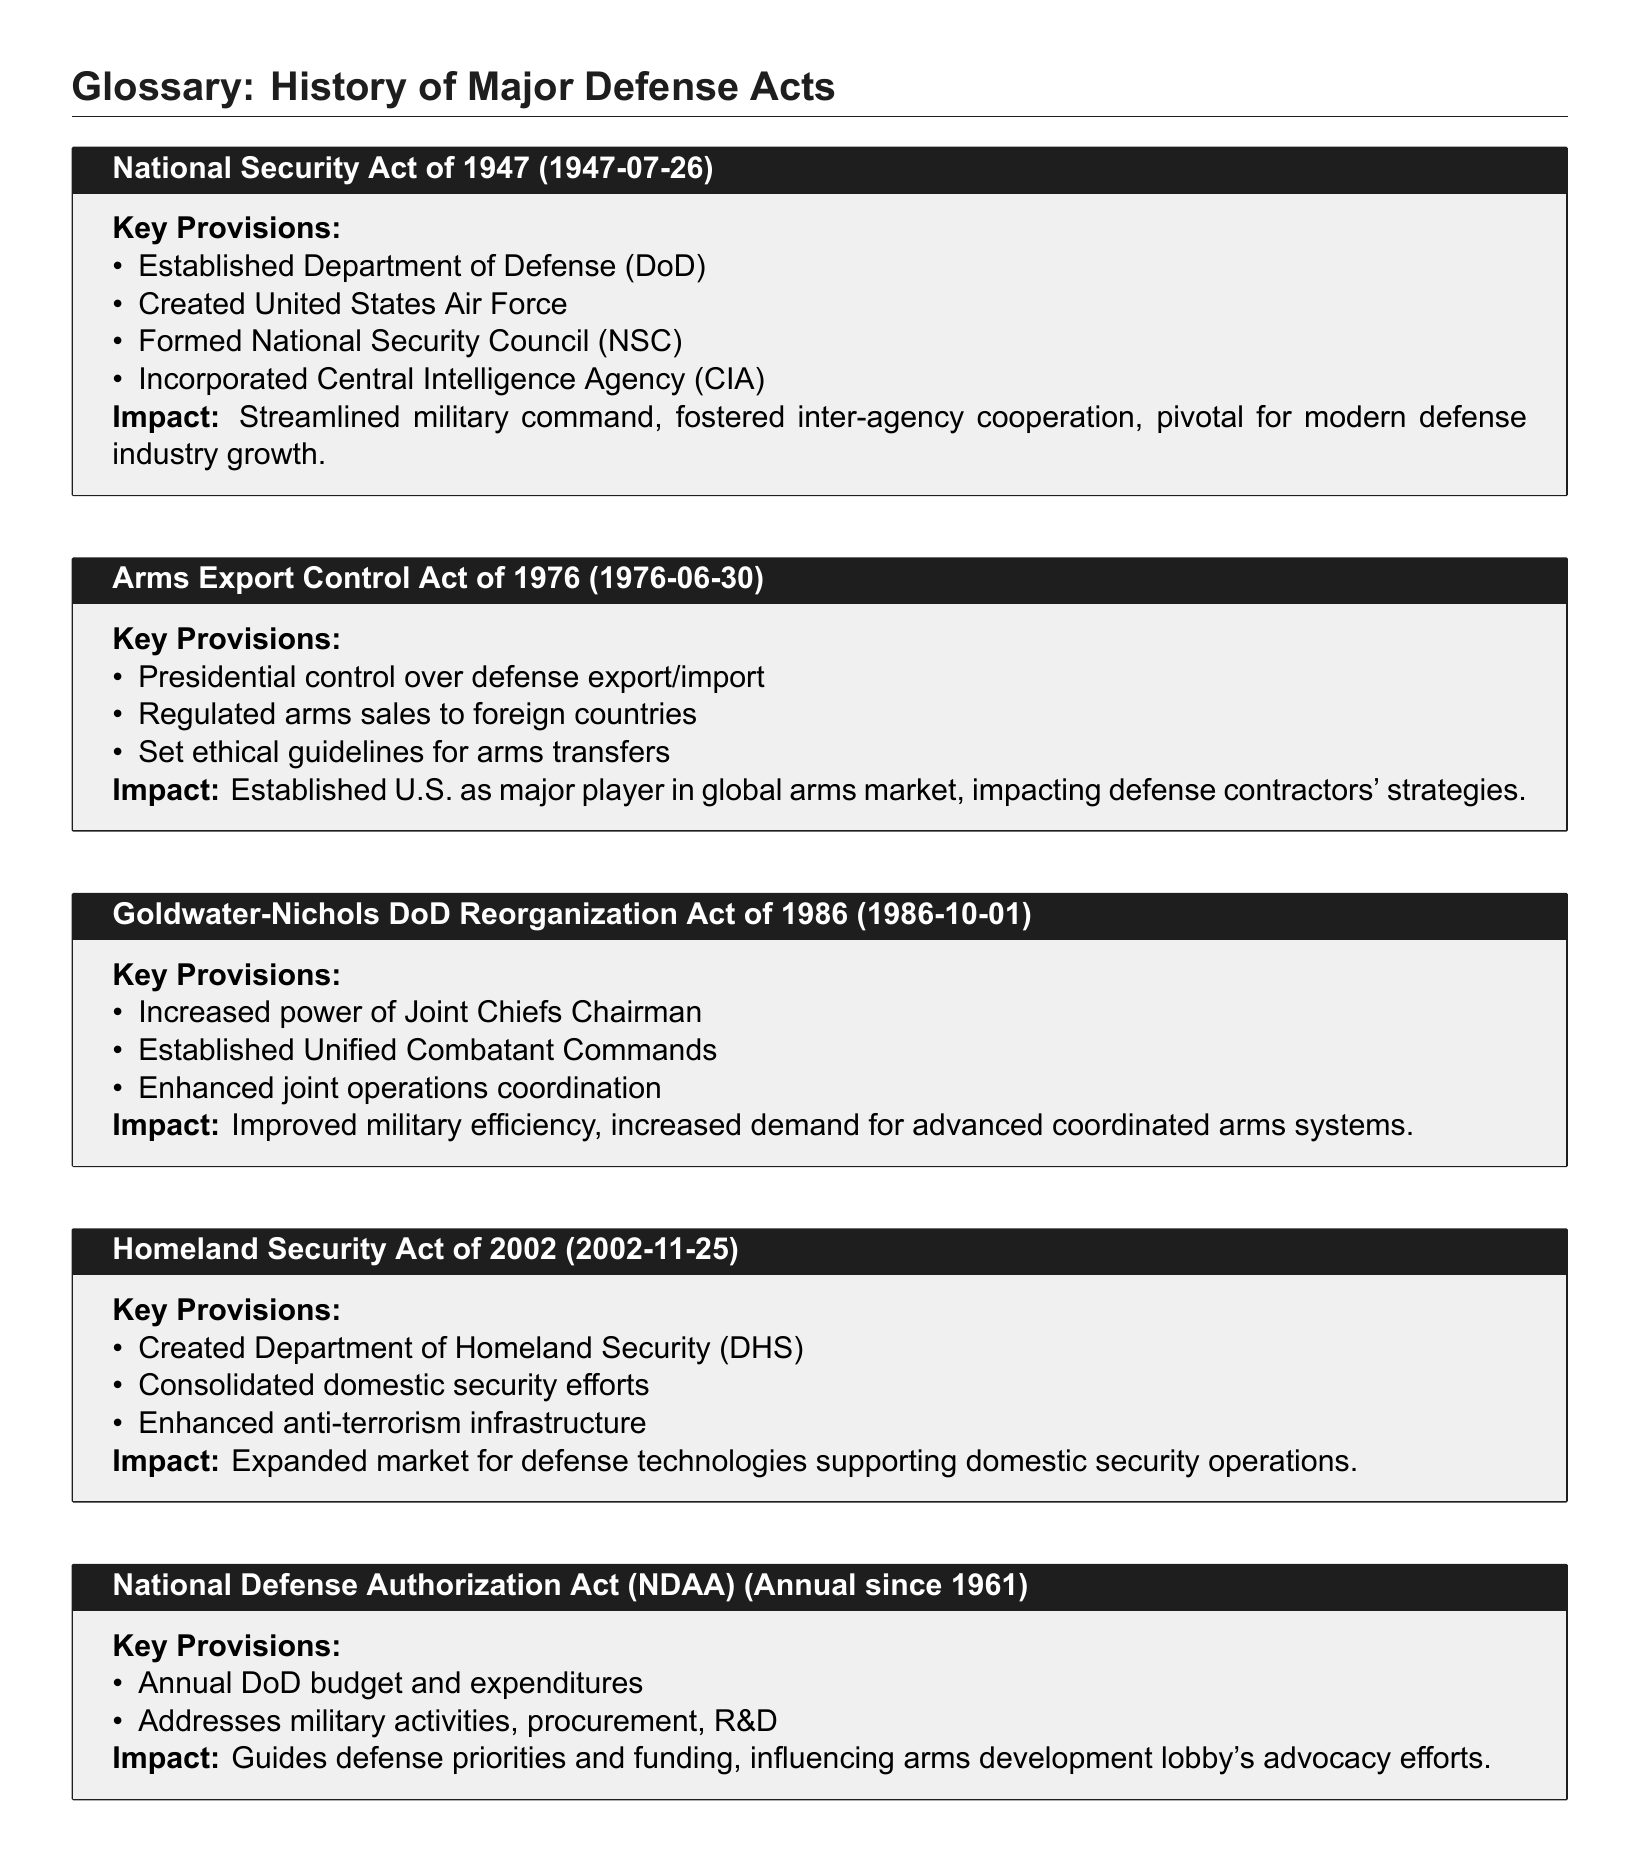What date was the National Security Act enacted? The National Security Act was enacted on July 26, 1947.
Answer: July 26, 1947 What agency was created by the National Security Act of 1947? The National Security Act created the United States Air Force.
Answer: United States Air Force Which act established presidential control over defense exports? The Arms Export Control Act of 1976 established presidential control over defense exports.
Answer: Arms Export Control Act of 1976 What is one impact of the Homeland Security Act of 2002? One impact of the Homeland Security Act of 2002 was the expansion of the market for defense technologies.
Answer: Expanded market for defense technologies How often is the National Defense Authorization Act enacted? The National Defense Authorization Act is enacted annually since 1961.
Answer: Annually since 1961 What did the Goldwater-Nichols DoD Reorganization Act of 1986 improve? The Goldwater-Nichols DoD Reorganization Act improved military efficiency.
Answer: Improved military efficiency Which act consolidated domestic security efforts? The Homeland Security Act of 2002 consolidated domestic security efforts.
Answer: Homeland Security Act of 2002 What date was the Arms Export Control Act enacted? The Arms Export Control Act was enacted on June 30, 1976.
Answer: June 30, 1976 What does the NDAA address? The NDAA addresses military activities, procurement, and R&D.
Answer: Military activities, procurement, R&D 